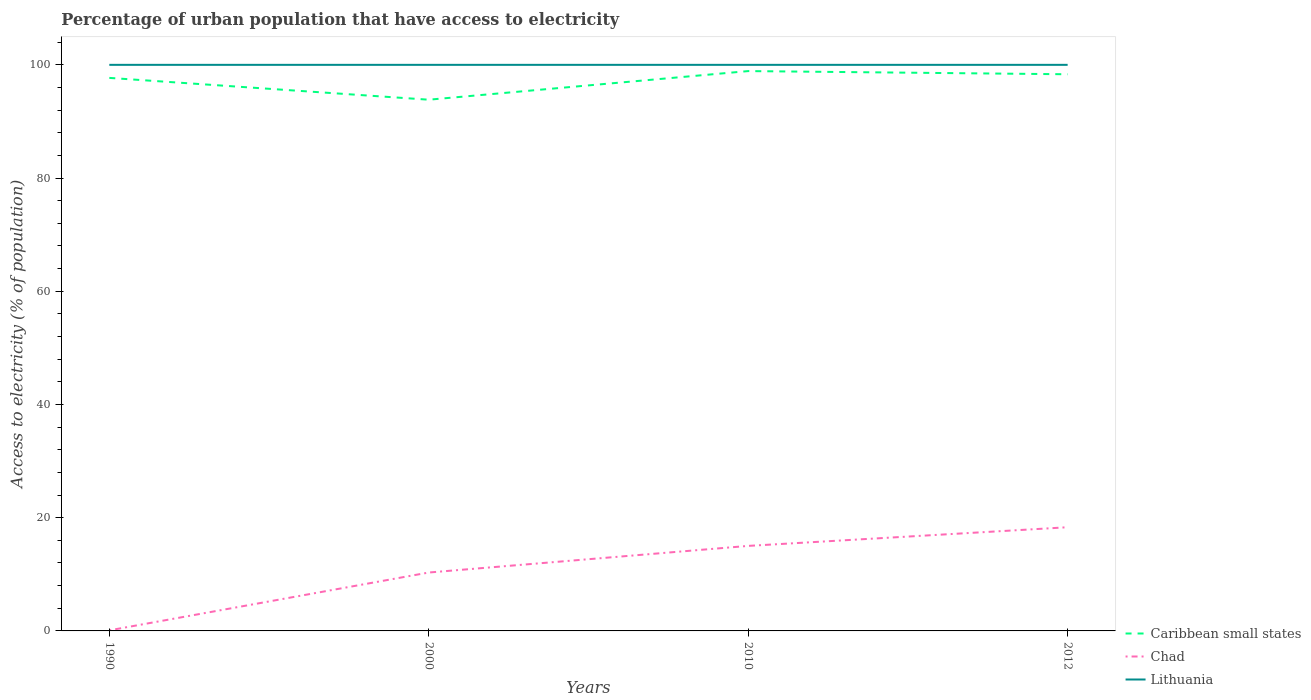Does the line corresponding to Caribbean small states intersect with the line corresponding to Lithuania?
Your response must be concise. No. Is the number of lines equal to the number of legend labels?
Give a very brief answer. Yes. What is the total percentage of urban population that have access to electricity in Caribbean small states in the graph?
Offer a terse response. -5.06. What is the difference between the highest and the second highest percentage of urban population that have access to electricity in Lithuania?
Your answer should be compact. 0. How many lines are there?
Provide a succinct answer. 3. How many years are there in the graph?
Your answer should be very brief. 4. Are the values on the major ticks of Y-axis written in scientific E-notation?
Give a very brief answer. No. Does the graph contain any zero values?
Offer a very short reply. No. How many legend labels are there?
Your answer should be very brief. 3. How are the legend labels stacked?
Give a very brief answer. Vertical. What is the title of the graph?
Your answer should be very brief. Percentage of urban population that have access to electricity. What is the label or title of the X-axis?
Give a very brief answer. Years. What is the label or title of the Y-axis?
Offer a terse response. Access to electricity (% of population). What is the Access to electricity (% of population) in Caribbean small states in 1990?
Your response must be concise. 97.7. What is the Access to electricity (% of population) of Chad in 1990?
Ensure brevity in your answer.  0.1. What is the Access to electricity (% of population) in Lithuania in 1990?
Your answer should be compact. 100. What is the Access to electricity (% of population) in Caribbean small states in 2000?
Keep it short and to the point. 93.84. What is the Access to electricity (% of population) in Chad in 2000?
Ensure brevity in your answer.  10.32. What is the Access to electricity (% of population) of Caribbean small states in 2010?
Offer a terse response. 98.9. What is the Access to electricity (% of population) in Chad in 2010?
Your answer should be compact. 15.02. What is the Access to electricity (% of population) of Lithuania in 2010?
Ensure brevity in your answer.  100. What is the Access to electricity (% of population) of Caribbean small states in 2012?
Provide a succinct answer. 98.34. What is the Access to electricity (% of population) in Chad in 2012?
Offer a terse response. 18.32. Across all years, what is the maximum Access to electricity (% of population) in Caribbean small states?
Keep it short and to the point. 98.9. Across all years, what is the maximum Access to electricity (% of population) of Chad?
Ensure brevity in your answer.  18.32. Across all years, what is the minimum Access to electricity (% of population) in Caribbean small states?
Provide a short and direct response. 93.84. What is the total Access to electricity (% of population) in Caribbean small states in the graph?
Provide a short and direct response. 388.77. What is the total Access to electricity (% of population) in Chad in the graph?
Offer a very short reply. 43.75. What is the total Access to electricity (% of population) of Lithuania in the graph?
Make the answer very short. 400. What is the difference between the Access to electricity (% of population) of Caribbean small states in 1990 and that in 2000?
Make the answer very short. 3.85. What is the difference between the Access to electricity (% of population) in Chad in 1990 and that in 2000?
Offer a terse response. -10.22. What is the difference between the Access to electricity (% of population) of Lithuania in 1990 and that in 2000?
Your answer should be very brief. 0. What is the difference between the Access to electricity (% of population) in Caribbean small states in 1990 and that in 2010?
Offer a very short reply. -1.2. What is the difference between the Access to electricity (% of population) of Chad in 1990 and that in 2010?
Your response must be concise. -14.92. What is the difference between the Access to electricity (% of population) in Caribbean small states in 1990 and that in 2012?
Provide a short and direct response. -0.64. What is the difference between the Access to electricity (% of population) of Chad in 1990 and that in 2012?
Make the answer very short. -18.22. What is the difference between the Access to electricity (% of population) of Caribbean small states in 2000 and that in 2010?
Your answer should be very brief. -5.06. What is the difference between the Access to electricity (% of population) of Chad in 2000 and that in 2010?
Offer a terse response. -4.7. What is the difference between the Access to electricity (% of population) in Lithuania in 2000 and that in 2010?
Offer a terse response. 0. What is the difference between the Access to electricity (% of population) of Caribbean small states in 2000 and that in 2012?
Offer a very short reply. -4.49. What is the difference between the Access to electricity (% of population) in Chad in 2000 and that in 2012?
Your response must be concise. -8. What is the difference between the Access to electricity (% of population) in Lithuania in 2000 and that in 2012?
Provide a succinct answer. 0. What is the difference between the Access to electricity (% of population) of Caribbean small states in 2010 and that in 2012?
Your answer should be very brief. 0.56. What is the difference between the Access to electricity (% of population) of Chad in 2010 and that in 2012?
Offer a very short reply. -3.3. What is the difference between the Access to electricity (% of population) of Caribbean small states in 1990 and the Access to electricity (% of population) of Chad in 2000?
Your answer should be very brief. 87.38. What is the difference between the Access to electricity (% of population) of Caribbean small states in 1990 and the Access to electricity (% of population) of Lithuania in 2000?
Offer a very short reply. -2.3. What is the difference between the Access to electricity (% of population) in Chad in 1990 and the Access to electricity (% of population) in Lithuania in 2000?
Provide a short and direct response. -99.9. What is the difference between the Access to electricity (% of population) in Caribbean small states in 1990 and the Access to electricity (% of population) in Chad in 2010?
Ensure brevity in your answer.  82.68. What is the difference between the Access to electricity (% of population) in Caribbean small states in 1990 and the Access to electricity (% of population) in Lithuania in 2010?
Your response must be concise. -2.3. What is the difference between the Access to electricity (% of population) in Chad in 1990 and the Access to electricity (% of population) in Lithuania in 2010?
Give a very brief answer. -99.9. What is the difference between the Access to electricity (% of population) in Caribbean small states in 1990 and the Access to electricity (% of population) in Chad in 2012?
Offer a terse response. 79.38. What is the difference between the Access to electricity (% of population) in Caribbean small states in 1990 and the Access to electricity (% of population) in Lithuania in 2012?
Make the answer very short. -2.3. What is the difference between the Access to electricity (% of population) in Chad in 1990 and the Access to electricity (% of population) in Lithuania in 2012?
Provide a succinct answer. -99.9. What is the difference between the Access to electricity (% of population) of Caribbean small states in 2000 and the Access to electricity (% of population) of Chad in 2010?
Your response must be concise. 78.82. What is the difference between the Access to electricity (% of population) in Caribbean small states in 2000 and the Access to electricity (% of population) in Lithuania in 2010?
Your response must be concise. -6.16. What is the difference between the Access to electricity (% of population) of Chad in 2000 and the Access to electricity (% of population) of Lithuania in 2010?
Offer a very short reply. -89.68. What is the difference between the Access to electricity (% of population) in Caribbean small states in 2000 and the Access to electricity (% of population) in Chad in 2012?
Keep it short and to the point. 75.53. What is the difference between the Access to electricity (% of population) in Caribbean small states in 2000 and the Access to electricity (% of population) in Lithuania in 2012?
Provide a succinct answer. -6.16. What is the difference between the Access to electricity (% of population) of Chad in 2000 and the Access to electricity (% of population) of Lithuania in 2012?
Your answer should be compact. -89.68. What is the difference between the Access to electricity (% of population) of Caribbean small states in 2010 and the Access to electricity (% of population) of Chad in 2012?
Ensure brevity in your answer.  80.58. What is the difference between the Access to electricity (% of population) in Caribbean small states in 2010 and the Access to electricity (% of population) in Lithuania in 2012?
Offer a terse response. -1.1. What is the difference between the Access to electricity (% of population) in Chad in 2010 and the Access to electricity (% of population) in Lithuania in 2012?
Provide a short and direct response. -84.98. What is the average Access to electricity (% of population) of Caribbean small states per year?
Make the answer very short. 97.19. What is the average Access to electricity (% of population) in Chad per year?
Your answer should be very brief. 10.94. What is the average Access to electricity (% of population) of Lithuania per year?
Give a very brief answer. 100. In the year 1990, what is the difference between the Access to electricity (% of population) in Caribbean small states and Access to electricity (% of population) in Chad?
Provide a succinct answer. 97.6. In the year 1990, what is the difference between the Access to electricity (% of population) of Caribbean small states and Access to electricity (% of population) of Lithuania?
Provide a short and direct response. -2.3. In the year 1990, what is the difference between the Access to electricity (% of population) of Chad and Access to electricity (% of population) of Lithuania?
Your answer should be compact. -99.9. In the year 2000, what is the difference between the Access to electricity (% of population) of Caribbean small states and Access to electricity (% of population) of Chad?
Provide a short and direct response. 83.53. In the year 2000, what is the difference between the Access to electricity (% of population) of Caribbean small states and Access to electricity (% of population) of Lithuania?
Your answer should be compact. -6.16. In the year 2000, what is the difference between the Access to electricity (% of population) in Chad and Access to electricity (% of population) in Lithuania?
Your answer should be compact. -89.68. In the year 2010, what is the difference between the Access to electricity (% of population) of Caribbean small states and Access to electricity (% of population) of Chad?
Your answer should be very brief. 83.88. In the year 2010, what is the difference between the Access to electricity (% of population) of Caribbean small states and Access to electricity (% of population) of Lithuania?
Offer a very short reply. -1.1. In the year 2010, what is the difference between the Access to electricity (% of population) of Chad and Access to electricity (% of population) of Lithuania?
Offer a very short reply. -84.98. In the year 2012, what is the difference between the Access to electricity (% of population) in Caribbean small states and Access to electricity (% of population) in Chad?
Make the answer very short. 80.02. In the year 2012, what is the difference between the Access to electricity (% of population) in Caribbean small states and Access to electricity (% of population) in Lithuania?
Make the answer very short. -1.66. In the year 2012, what is the difference between the Access to electricity (% of population) in Chad and Access to electricity (% of population) in Lithuania?
Keep it short and to the point. -81.68. What is the ratio of the Access to electricity (% of population) in Caribbean small states in 1990 to that in 2000?
Keep it short and to the point. 1.04. What is the ratio of the Access to electricity (% of population) of Chad in 1990 to that in 2000?
Your response must be concise. 0.01. What is the ratio of the Access to electricity (% of population) in Lithuania in 1990 to that in 2000?
Provide a succinct answer. 1. What is the ratio of the Access to electricity (% of population) in Caribbean small states in 1990 to that in 2010?
Offer a terse response. 0.99. What is the ratio of the Access to electricity (% of population) in Chad in 1990 to that in 2010?
Your answer should be compact. 0.01. What is the ratio of the Access to electricity (% of population) of Lithuania in 1990 to that in 2010?
Keep it short and to the point. 1. What is the ratio of the Access to electricity (% of population) in Caribbean small states in 1990 to that in 2012?
Your answer should be very brief. 0.99. What is the ratio of the Access to electricity (% of population) in Chad in 1990 to that in 2012?
Give a very brief answer. 0.01. What is the ratio of the Access to electricity (% of population) in Caribbean small states in 2000 to that in 2010?
Your answer should be compact. 0.95. What is the ratio of the Access to electricity (% of population) in Chad in 2000 to that in 2010?
Provide a succinct answer. 0.69. What is the ratio of the Access to electricity (% of population) of Lithuania in 2000 to that in 2010?
Your answer should be compact. 1. What is the ratio of the Access to electricity (% of population) of Caribbean small states in 2000 to that in 2012?
Your response must be concise. 0.95. What is the ratio of the Access to electricity (% of population) in Chad in 2000 to that in 2012?
Make the answer very short. 0.56. What is the ratio of the Access to electricity (% of population) of Caribbean small states in 2010 to that in 2012?
Ensure brevity in your answer.  1.01. What is the ratio of the Access to electricity (% of population) of Chad in 2010 to that in 2012?
Provide a succinct answer. 0.82. What is the difference between the highest and the second highest Access to electricity (% of population) of Caribbean small states?
Your answer should be very brief. 0.56. What is the difference between the highest and the second highest Access to electricity (% of population) in Chad?
Ensure brevity in your answer.  3.3. What is the difference between the highest and the second highest Access to electricity (% of population) in Lithuania?
Provide a succinct answer. 0. What is the difference between the highest and the lowest Access to electricity (% of population) in Caribbean small states?
Your answer should be compact. 5.06. What is the difference between the highest and the lowest Access to electricity (% of population) of Chad?
Your response must be concise. 18.22. 